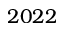Convert formula to latex. <formula><loc_0><loc_0><loc_500><loc_500>2 0 2 2</formula> 